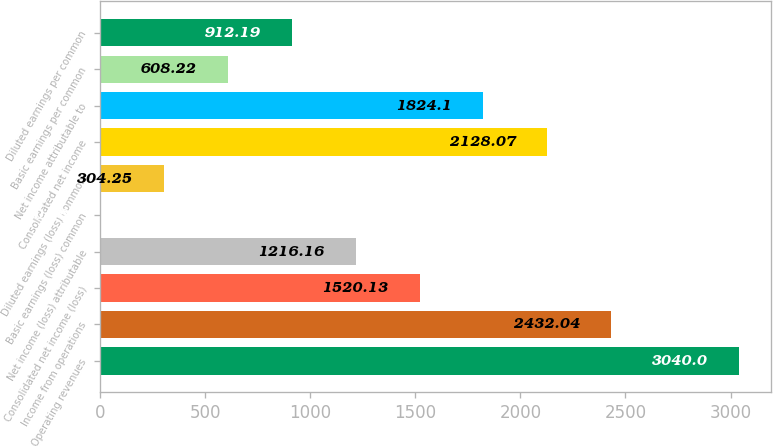Convert chart to OTSL. <chart><loc_0><loc_0><loc_500><loc_500><bar_chart><fcel>Operating revenues<fcel>Income from operations<fcel>Consolidated net income (loss)<fcel>Net income (loss) attributable<fcel>Basic earnings (loss) common<fcel>Diluted earnings (loss) common<fcel>Consolidated net income<fcel>Net income attributable to<fcel>Basic earnings per common<fcel>Diluted earnings per common<nl><fcel>3040<fcel>2432.04<fcel>1520.13<fcel>1216.16<fcel>0.28<fcel>304.25<fcel>2128.07<fcel>1824.1<fcel>608.22<fcel>912.19<nl></chart> 